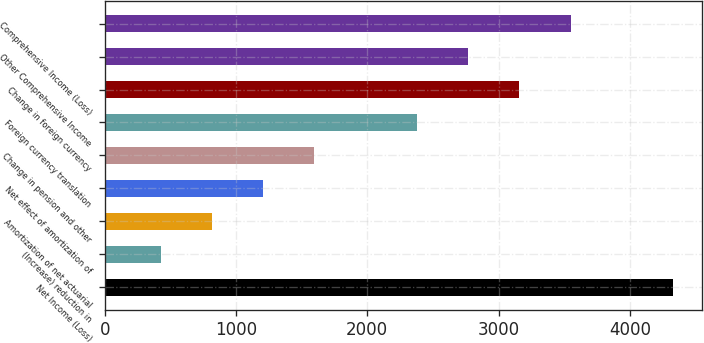<chart> <loc_0><loc_0><loc_500><loc_500><bar_chart><fcel>Net Income (Loss)<fcel>(Increase) reduction in<fcel>Amortization of net actuarial<fcel>Net effect of amortization of<fcel>Change in pension and other<fcel>Foreign currency translation<fcel>Change in foreign currency<fcel>Other Comprehensive Income<fcel>Comprehensive Income (Loss)<nl><fcel>4331.6<fcel>425.6<fcel>816.2<fcel>1206.8<fcel>1597.4<fcel>2378.6<fcel>3159.8<fcel>2769.2<fcel>3550.4<nl></chart> 